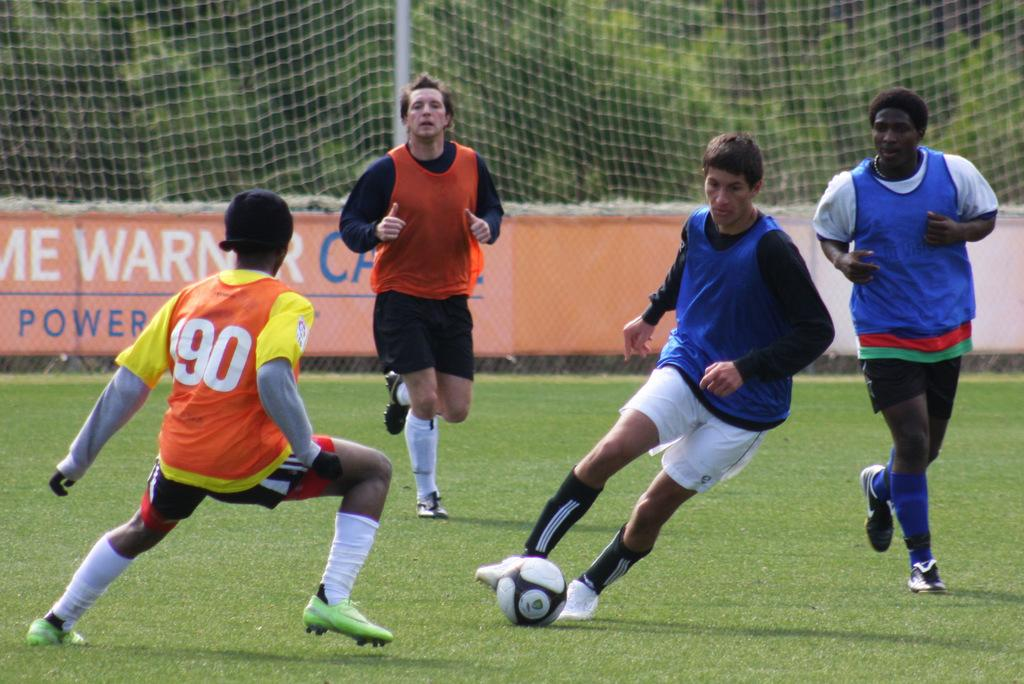<image>
Provide a brief description of the given image. Player 190 tries to get possession of the ball. 